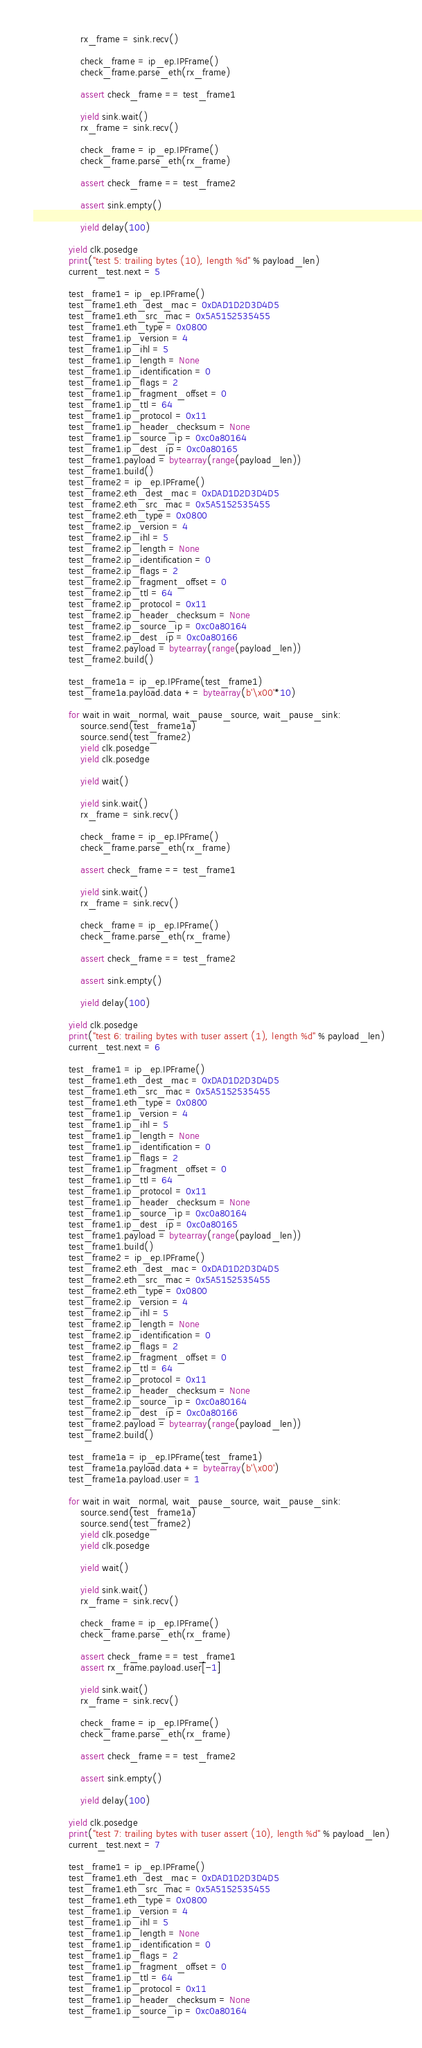<code> <loc_0><loc_0><loc_500><loc_500><_Python_>                rx_frame = sink.recv()

                check_frame = ip_ep.IPFrame()
                check_frame.parse_eth(rx_frame)

                assert check_frame == test_frame1

                yield sink.wait()
                rx_frame = sink.recv()

                check_frame = ip_ep.IPFrame()
                check_frame.parse_eth(rx_frame)

                assert check_frame == test_frame2

                assert sink.empty()

                yield delay(100)

            yield clk.posedge
            print("test 5: trailing bytes (10), length %d" % payload_len)
            current_test.next = 5

            test_frame1 = ip_ep.IPFrame()
            test_frame1.eth_dest_mac = 0xDAD1D2D3D4D5
            test_frame1.eth_src_mac = 0x5A5152535455
            test_frame1.eth_type = 0x0800
            test_frame1.ip_version = 4
            test_frame1.ip_ihl = 5
            test_frame1.ip_length = None
            test_frame1.ip_identification = 0
            test_frame1.ip_flags = 2
            test_frame1.ip_fragment_offset = 0
            test_frame1.ip_ttl = 64
            test_frame1.ip_protocol = 0x11
            test_frame1.ip_header_checksum = None
            test_frame1.ip_source_ip = 0xc0a80164
            test_frame1.ip_dest_ip = 0xc0a80165
            test_frame1.payload = bytearray(range(payload_len))
            test_frame1.build()
            test_frame2 = ip_ep.IPFrame()
            test_frame2.eth_dest_mac = 0xDAD1D2D3D4D5
            test_frame2.eth_src_mac = 0x5A5152535455
            test_frame2.eth_type = 0x0800
            test_frame2.ip_version = 4
            test_frame2.ip_ihl = 5
            test_frame2.ip_length = None
            test_frame2.ip_identification = 0
            test_frame2.ip_flags = 2
            test_frame2.ip_fragment_offset = 0
            test_frame2.ip_ttl = 64
            test_frame2.ip_protocol = 0x11
            test_frame2.ip_header_checksum = None
            test_frame2.ip_source_ip = 0xc0a80164
            test_frame2.ip_dest_ip = 0xc0a80166
            test_frame2.payload = bytearray(range(payload_len))
            test_frame2.build()

            test_frame1a = ip_ep.IPFrame(test_frame1)
            test_frame1a.payload.data += bytearray(b'\x00'*10)

            for wait in wait_normal, wait_pause_source, wait_pause_sink:
                source.send(test_frame1a)
                source.send(test_frame2)
                yield clk.posedge
                yield clk.posedge

                yield wait()

                yield sink.wait()
                rx_frame = sink.recv()

                check_frame = ip_ep.IPFrame()
                check_frame.parse_eth(rx_frame)

                assert check_frame == test_frame1

                yield sink.wait()
                rx_frame = sink.recv()

                check_frame = ip_ep.IPFrame()
                check_frame.parse_eth(rx_frame)

                assert check_frame == test_frame2

                assert sink.empty()

                yield delay(100)

            yield clk.posedge
            print("test 6: trailing bytes with tuser assert (1), length %d" % payload_len)
            current_test.next = 6

            test_frame1 = ip_ep.IPFrame()
            test_frame1.eth_dest_mac = 0xDAD1D2D3D4D5
            test_frame1.eth_src_mac = 0x5A5152535455
            test_frame1.eth_type = 0x0800
            test_frame1.ip_version = 4
            test_frame1.ip_ihl = 5
            test_frame1.ip_length = None
            test_frame1.ip_identification = 0
            test_frame1.ip_flags = 2
            test_frame1.ip_fragment_offset = 0
            test_frame1.ip_ttl = 64
            test_frame1.ip_protocol = 0x11
            test_frame1.ip_header_checksum = None
            test_frame1.ip_source_ip = 0xc0a80164
            test_frame1.ip_dest_ip = 0xc0a80165
            test_frame1.payload = bytearray(range(payload_len))
            test_frame1.build()
            test_frame2 = ip_ep.IPFrame()
            test_frame2.eth_dest_mac = 0xDAD1D2D3D4D5
            test_frame2.eth_src_mac = 0x5A5152535455
            test_frame2.eth_type = 0x0800
            test_frame2.ip_version = 4
            test_frame2.ip_ihl = 5
            test_frame2.ip_length = None
            test_frame2.ip_identification = 0
            test_frame2.ip_flags = 2
            test_frame2.ip_fragment_offset = 0
            test_frame2.ip_ttl = 64
            test_frame2.ip_protocol = 0x11
            test_frame2.ip_header_checksum = None
            test_frame2.ip_source_ip = 0xc0a80164
            test_frame2.ip_dest_ip = 0xc0a80166
            test_frame2.payload = bytearray(range(payload_len))
            test_frame2.build()

            test_frame1a = ip_ep.IPFrame(test_frame1)
            test_frame1a.payload.data += bytearray(b'\x00')
            test_frame1a.payload.user = 1

            for wait in wait_normal, wait_pause_source, wait_pause_sink:
                source.send(test_frame1a)
                source.send(test_frame2)
                yield clk.posedge
                yield clk.posedge

                yield wait()

                yield sink.wait()
                rx_frame = sink.recv()

                check_frame = ip_ep.IPFrame()
                check_frame.parse_eth(rx_frame)

                assert check_frame == test_frame1
                assert rx_frame.payload.user[-1]

                yield sink.wait()
                rx_frame = sink.recv()

                check_frame = ip_ep.IPFrame()
                check_frame.parse_eth(rx_frame)

                assert check_frame == test_frame2

                assert sink.empty()

                yield delay(100)

            yield clk.posedge
            print("test 7: trailing bytes with tuser assert (10), length %d" % payload_len)
            current_test.next = 7

            test_frame1 = ip_ep.IPFrame()
            test_frame1.eth_dest_mac = 0xDAD1D2D3D4D5
            test_frame1.eth_src_mac = 0x5A5152535455
            test_frame1.eth_type = 0x0800
            test_frame1.ip_version = 4
            test_frame1.ip_ihl = 5
            test_frame1.ip_length = None
            test_frame1.ip_identification = 0
            test_frame1.ip_flags = 2
            test_frame1.ip_fragment_offset = 0
            test_frame1.ip_ttl = 64
            test_frame1.ip_protocol = 0x11
            test_frame1.ip_header_checksum = None
            test_frame1.ip_source_ip = 0xc0a80164</code> 